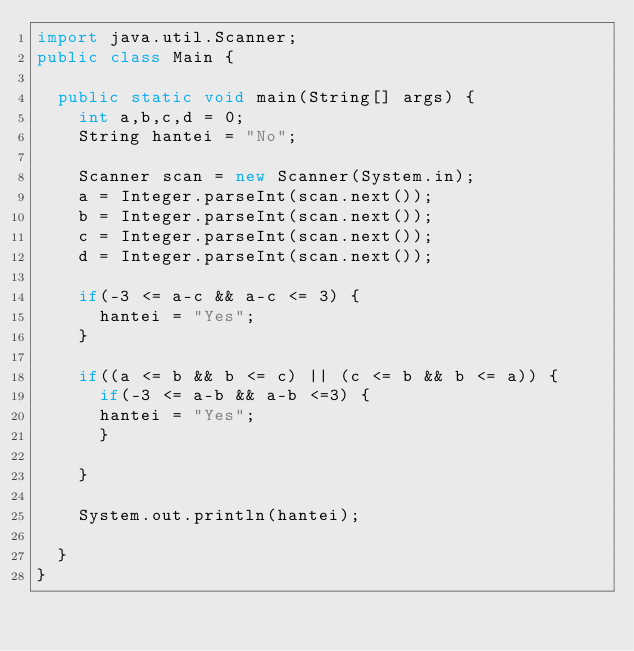Convert code to text. <code><loc_0><loc_0><loc_500><loc_500><_Java_>import java.util.Scanner;
public class Main {

	public static void main(String[] args) {
		int a,b,c,d = 0;
		String hantei = "No";

		Scanner scan = new Scanner(System.in);
		a = Integer.parseInt(scan.next());
		b = Integer.parseInt(scan.next());
		c = Integer.parseInt(scan.next());
		d = Integer.parseInt(scan.next());

		if(-3 <= a-c && a-c <= 3) {
			hantei = "Yes";
		}

		if((a <= b && b <= c) || (c <= b && b <= a)) {
			if(-3 <= a-b && a-b <=3) {
			hantei = "Yes";
			}

		}

		System.out.println(hantei);

	}
}
</code> 